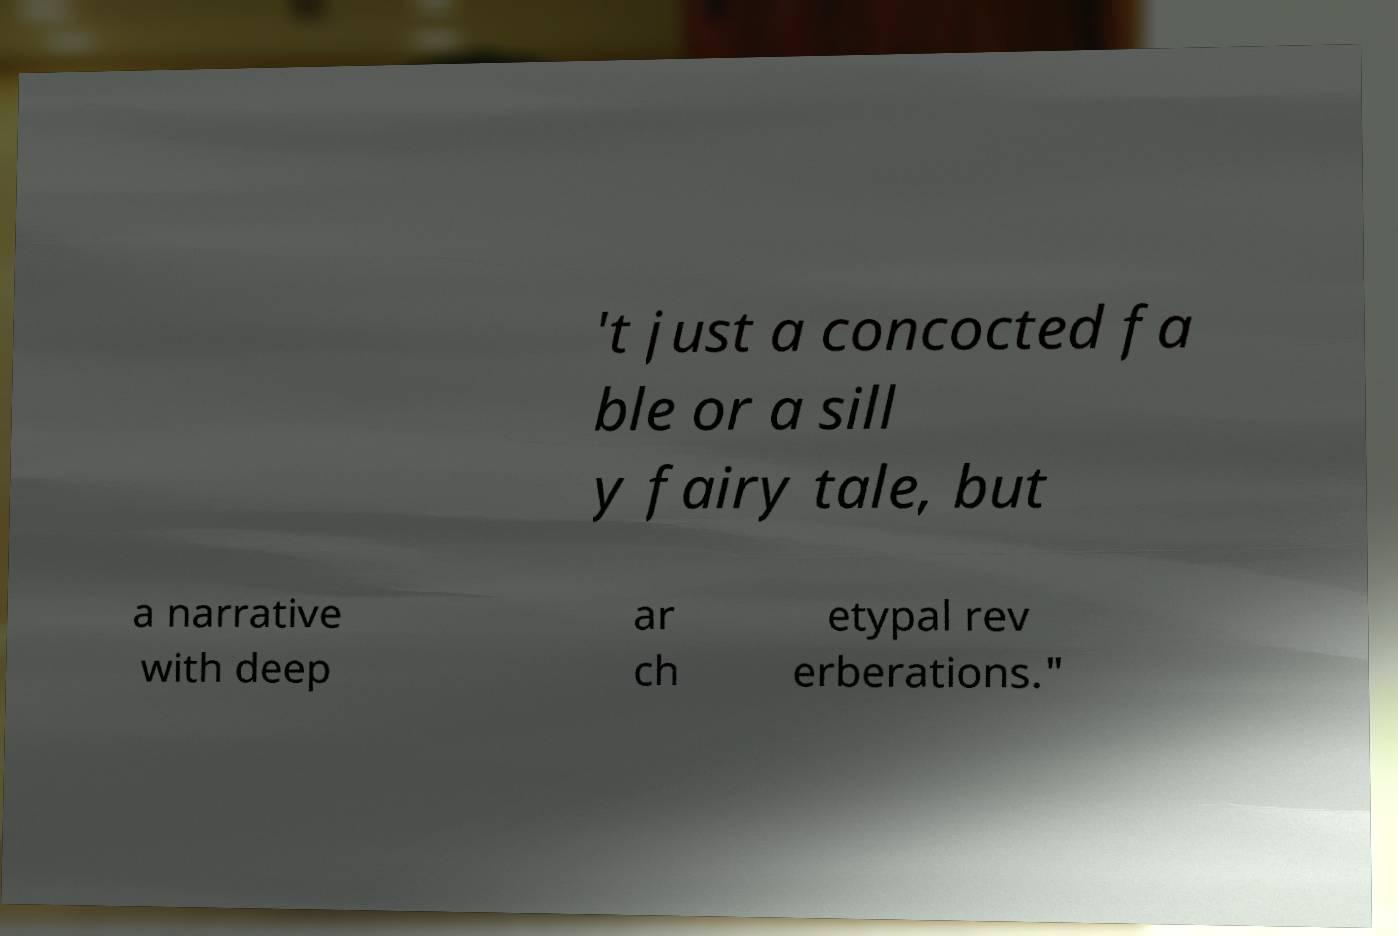Can you read and provide the text displayed in the image?This photo seems to have some interesting text. Can you extract and type it out for me? 't just a concocted fa ble or a sill y fairy tale, but a narrative with deep ar ch etypal rev erberations." 